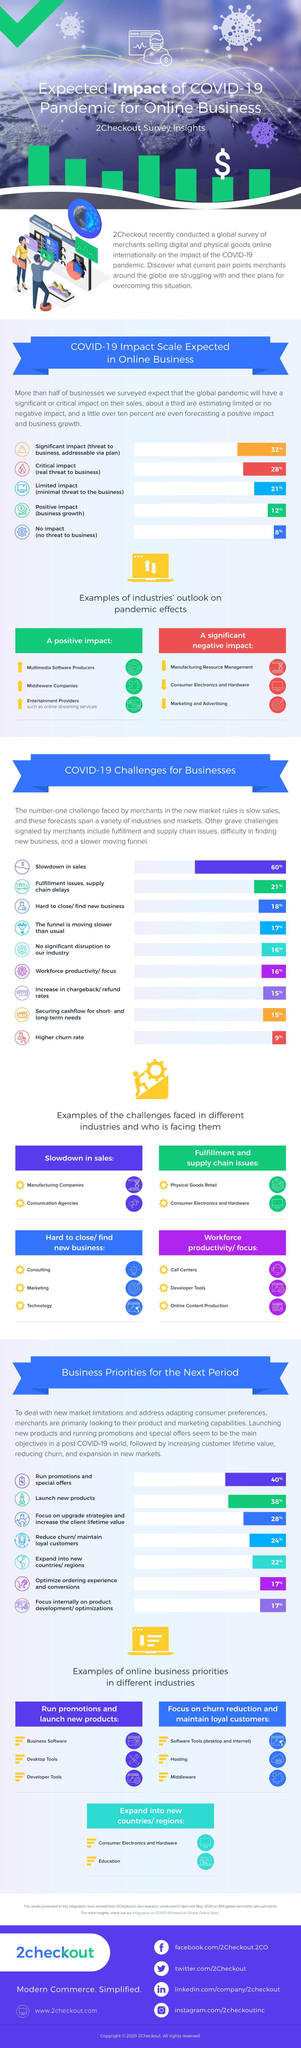What type of challenge was faced by call centers?
Answer the question with a short phrase. workforce productivity/ focus Which are the two industry types listed which had a slowdown in sales? manufacturing companies, comunication agencies What was the challenge faced by consulting and technology industries? hard to close/ find new business What impact did the pandemic have on manufacturing resource management ? a significant negative impact What is the online business priority for the Business software industry? Run promotions and launch new products What type of challenge was faced by Physical goods retail industry? fulfillment and supply chain issues What is the online business priority for the education industry? Expand into new countries/ regions Which is the second industry listed which had to face a significant negative impact due to the pandemic? consumer electronics and hardware What impact did the pandemic have on online streaming services ? A positive impact Which is the second industry listed which had a positive impact due to the pandemic? middleware companies 